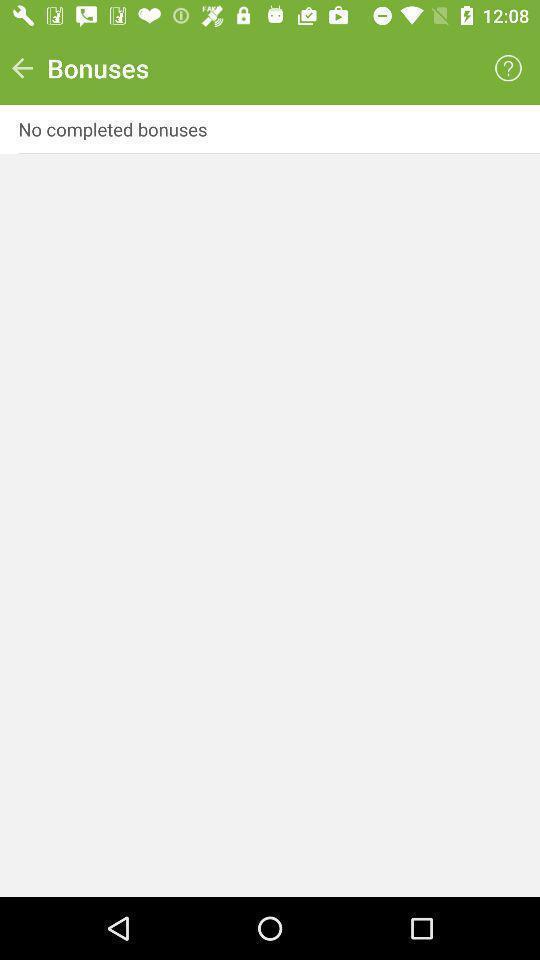Summarize the main components in this picture. Screen shows bonuses. 